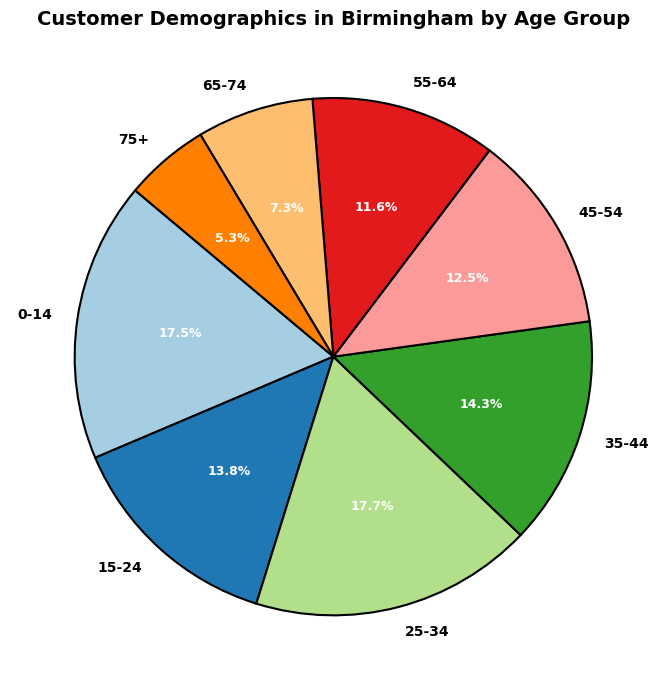What's the largest age group in the customer demographics? By looking at the pie chart, we can see which age group represents the largest portion of the pie. The segment labeled "25-34" is the largest.
Answer: 25-34 Which age group has the smallest percentage of customers? By reviewing the slices in the pie chart and their associated percentages, we can observe that the "75+" age group is the smallest.
Answer: 75+ What's the combined percentage of customers aged below 25? Add the percentages of the "0-14" and "15-24" age groups: 17.5% + 13.8% = 31.3%.
Answer: 31.3% Which age group is more prevalent, 15-24 or 45-54? Comparing the segments, "15-24" has 13.8% whereas "45-54" has 12.5%, making the 15-24 age group more prevalent.
Answer: 15-24 What is the total percentage of customers aged 35-54? Sum the percentages of the "35-44" and "45-54" age groups: 14.3% + 12.5% = 26.8%.
Answer: 26.8% Is the percentage of customers aged 55-64 more or less than that of customers aged 15-24? Comparing the percentages, 55-64 is 11.6% while 15-24 is 13.8%. The percentage of 55-64 is less than that of 15-24.
Answer: Less What's the difference in percentage between the largest and smallest age groups? Subtract the smallest percentage (75+) from the largest percentage (25-34): 17.7% - 5.3% = 12.4%.
Answer: 12.4% What is the combined percentage of customers aged 0-14 and 65+? Sum the percentages of "0-14" and "65-74" and "75+": 17.5% + 7.3% + 5.3% = 30.1%.
Answer: 30.1% What percentage of customers are aged 45-64? Sum the percentages of the "45-54" and "55-64" age groups: 12.5% + 11.6% = 24.1%.
Answer: 24.1% Which age group is represented by the orange section of the pie chart? By visually identifying the orange section of the pie chart and matching it with the legend, we see that it corresponds to the "55-64" age group.
Answer: 55-64 